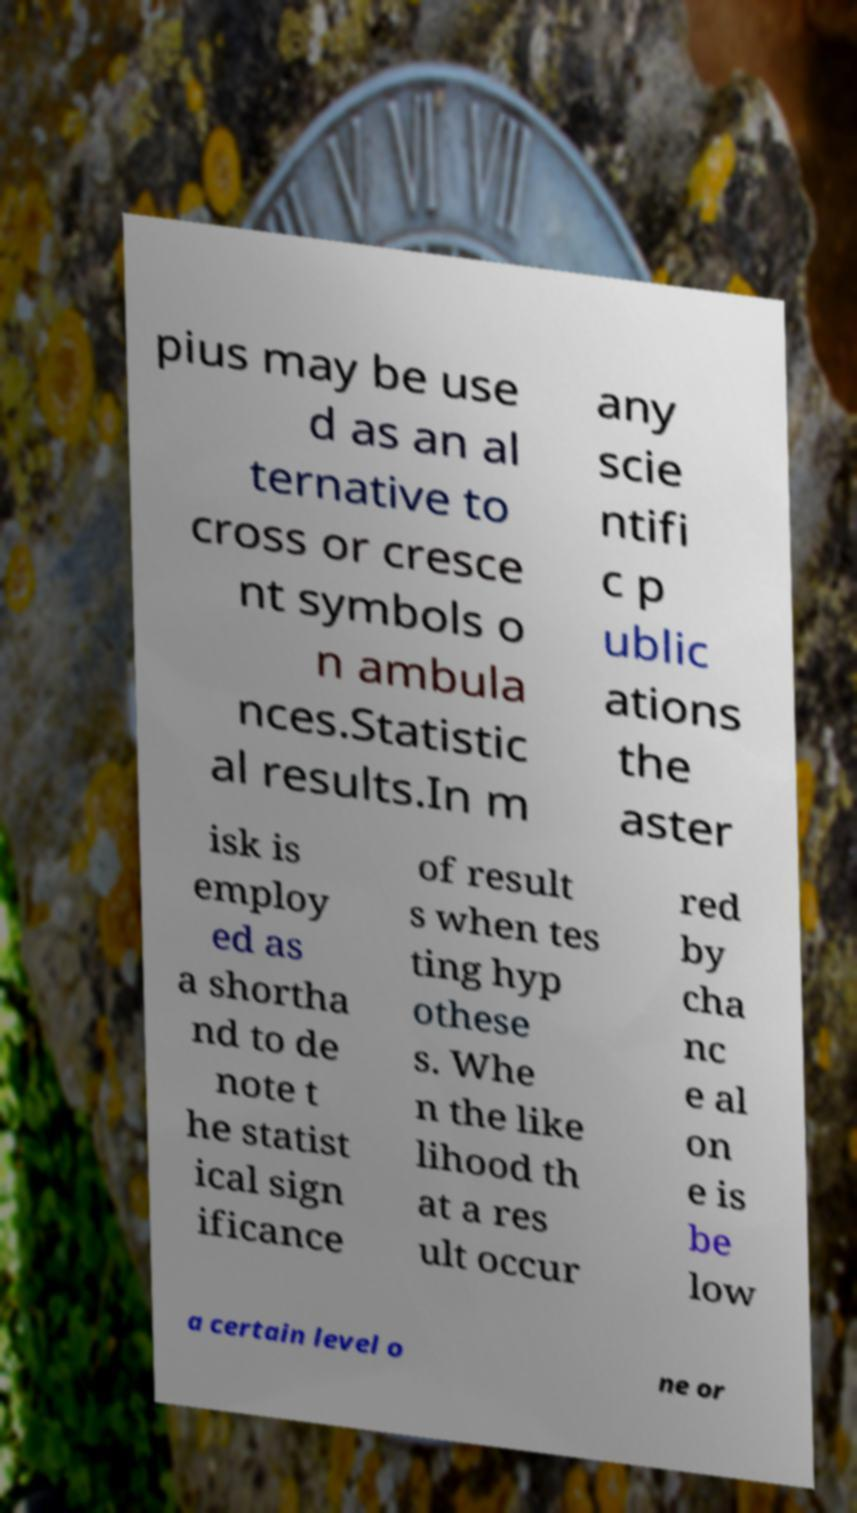Please read and relay the text visible in this image. What does it say? pius may be use d as an al ternative to cross or cresce nt symbols o n ambula nces.Statistic al results.In m any scie ntifi c p ublic ations the aster isk is employ ed as a shortha nd to de note t he statist ical sign ificance of result s when tes ting hyp othese s. Whe n the like lihood th at a res ult occur red by cha nc e al on e is be low a certain level o ne or 